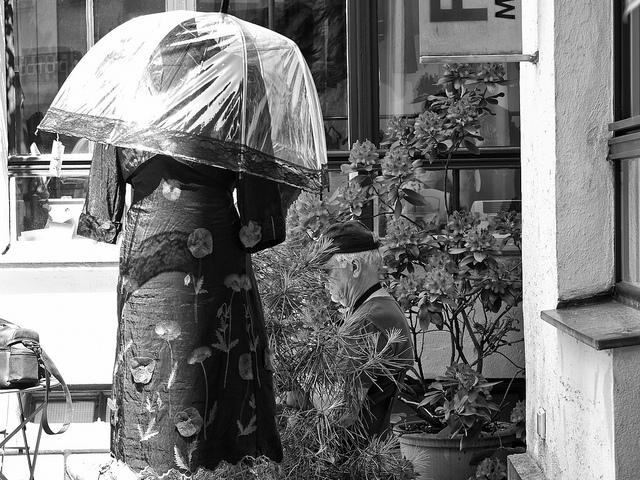Why no hands or head? Please explain your reasoning. is mannequin. Her hands are under the sleeves. 